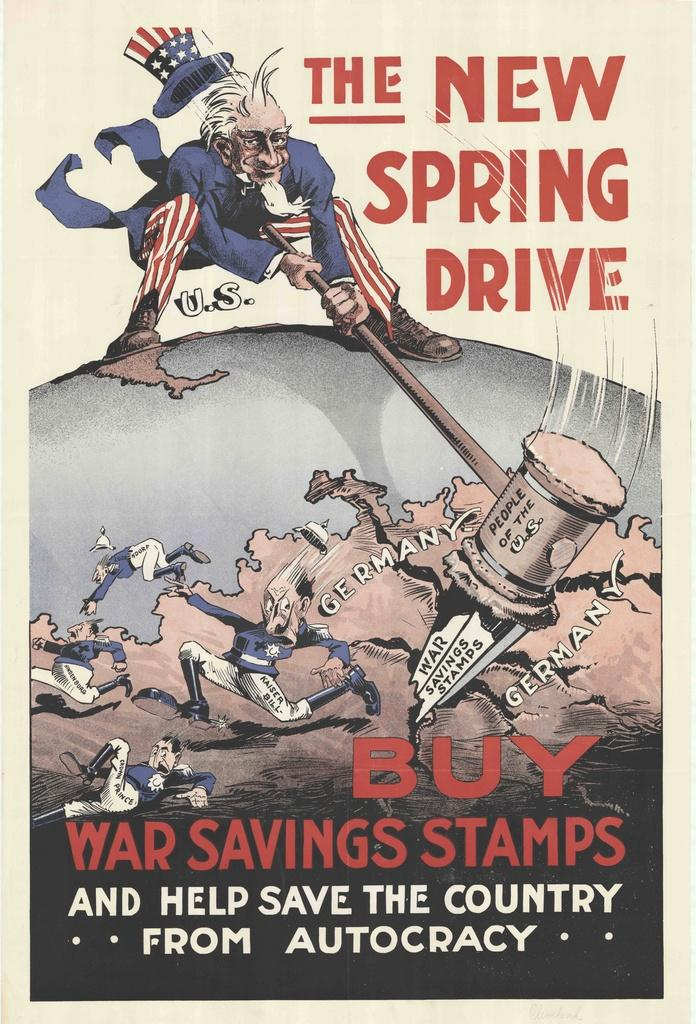What is present in the image that contains information or a message? There is a poster in the image that contains text. What type of images are on the poster? The poster contains cartoon pictures. Who is the owner of the curve mentioned in the poster? There is no mention of a curve or an owner in the image or the poster. 